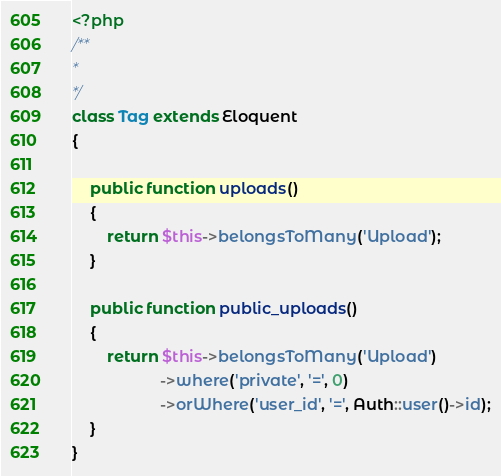<code> <loc_0><loc_0><loc_500><loc_500><_PHP_><?php
/**
* 
*/
class Tag extends Eloquent
{
	
	public function uploads()
	{
		return $this->belongsToMany('Upload');
	}
	
	public function public_uploads()
	{
		return $this->belongsToMany('Upload')
					->where('private', '=', 0)
					->orWhere('user_id', '=', Auth::user()->id);
	}
}</code> 